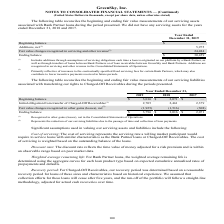According to Greensky's financial document, What does the net Fair value changes recognized in other gains (losses) represent? the reduction of our servicing liabilities due to the passage of time and collection of loan payments.. The document states: "(2) Represents the reduction of our servicing liabilities due to the passage of time and collection of loan payments...." Also, What was the beginning balance in 2018? According to the financial document, 2,071 (in thousands). The relevant text states: "Beginning balance $ 3,016 $ 2,071 $ — Initial obligation from transfer of Charged-Off Receivables (1) 2,705 2,461 2,379 Fair value ch..." Also, Which years does the table show? The document contains multiple relevant values: 2019, 2018, 2017. From the document: "Year Ended December 31, 2019 2018 2017 Year Ended December 31, 2019 2018 2017 Year Ended December 31, 2019 2018 2017..." Additionally, Which years did the ending balance exceed $3,000 thousand? The document shows two values: 2019 and 2018. From the document: "Year Ended December 31, 2019 2018 2017 Year Ended December 31, 2019 2018 2017..." Also, can you calculate: What was the change in the beginning balance between 2018 and 2019? Based on the calculation: 3,016-2,071, the result is 945 (in thousands). This is based on the information: "Beginning balance $ 3,016 $ 2,071 $ — Initial obligation from transfer of Charged-Off Receivables (1) 2,705 2,461 2,379 Fair Beginning balance $ 3,016 $ 2,071 $ — Initial obligation from transfer of C..." The key data points involved are: 2,071, 3,016. Also, can you calculate: What was the percentage change in the Initial obligation from transfer of Charged-Off Receivables between 2018 and 2019? To answer this question, I need to perform calculations using the financial data. The calculation is: (2,705-2,461)/2,461, which equals 9.91 (percentage). This is based on the information: "tion from transfer of Charged-Off Receivables (1) 2,705 2,461 2,379 Fair value changes recognized in other gains (losses), net (2) (1,925) (1,516) (308) rom transfer of Charged-Off Receivables (1) 2,7..." The key data points involved are: 2,461, 2,705. 